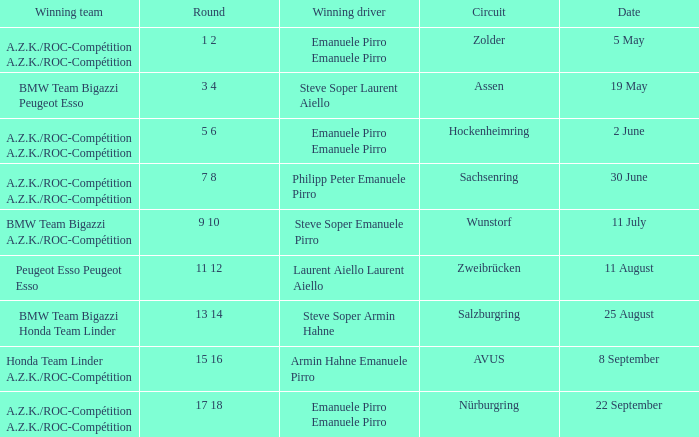What was the winning team on 11 July? BMW Team Bigazzi A.Z.K./ROC-Compétition. 